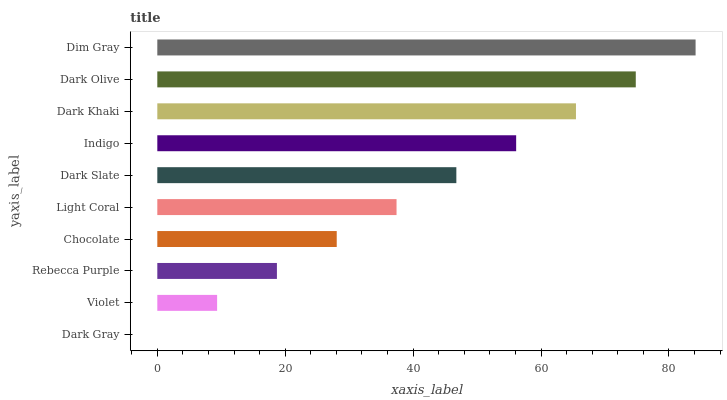Is Dark Gray the minimum?
Answer yes or no. Yes. Is Dim Gray the maximum?
Answer yes or no. Yes. Is Violet the minimum?
Answer yes or no. No. Is Violet the maximum?
Answer yes or no. No. Is Violet greater than Dark Gray?
Answer yes or no. Yes. Is Dark Gray less than Violet?
Answer yes or no. Yes. Is Dark Gray greater than Violet?
Answer yes or no. No. Is Violet less than Dark Gray?
Answer yes or no. No. Is Dark Slate the high median?
Answer yes or no. Yes. Is Light Coral the low median?
Answer yes or no. Yes. Is Dark Khaki the high median?
Answer yes or no. No. Is Dark Olive the low median?
Answer yes or no. No. 